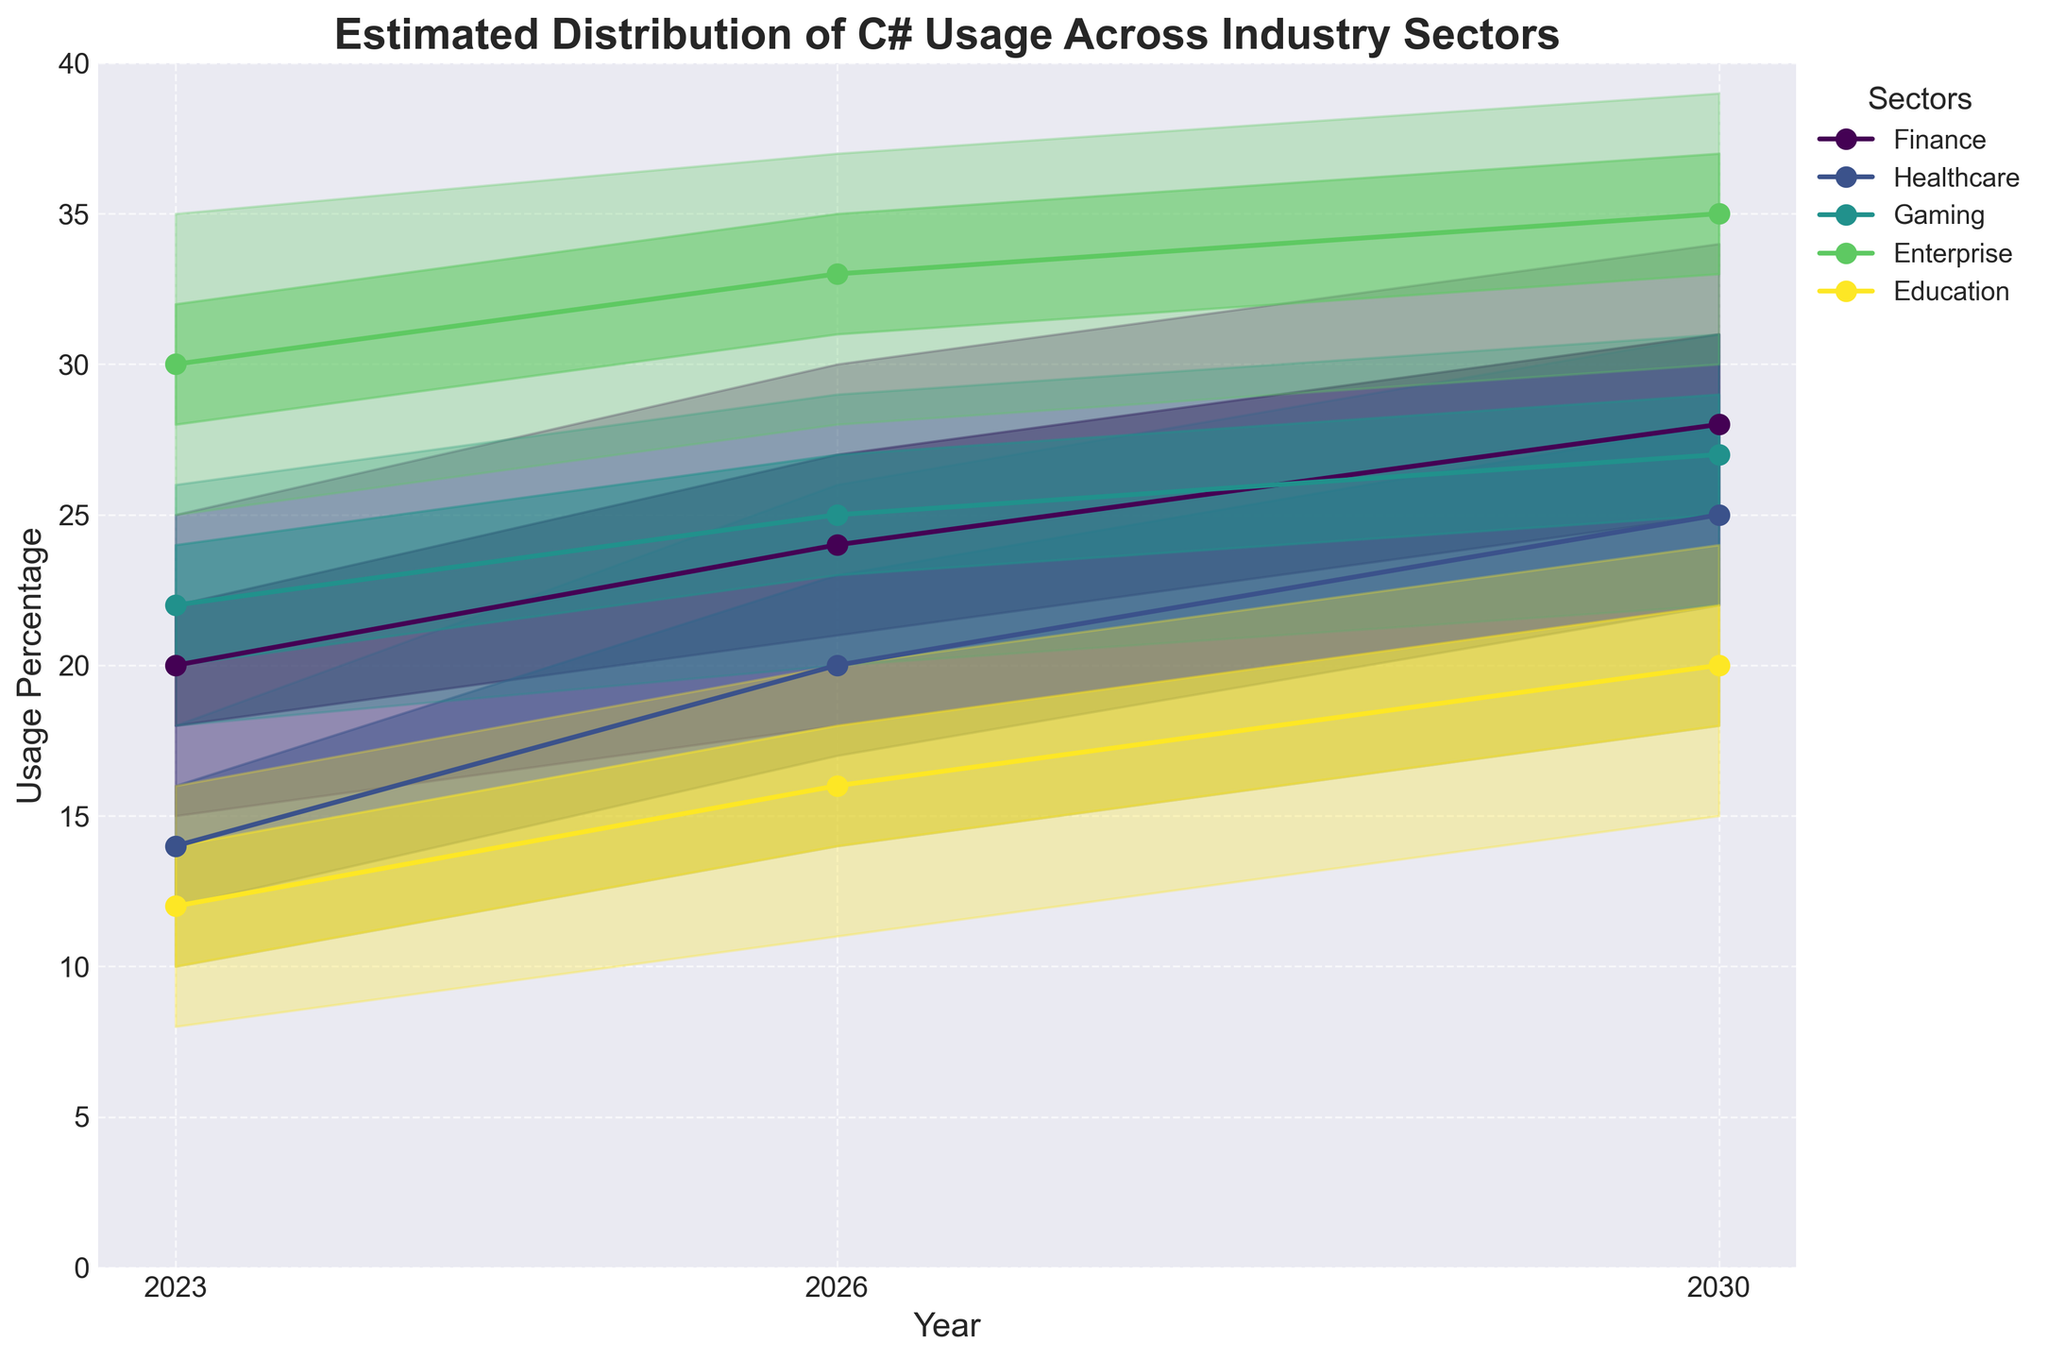How many industry sectors are represented in the chart? There are 5 unique sectors listed in the data table: Finance, Healthcare, Gaming, Enterprise, and Education
Answer: 5 What is the title of the chart? The title of the chart is displayed at the top of the figure.
Answer: Estimated Distribution of C# Usage Across Industry Sectors Which sector has the highest median estimated usage in 2023? Look at the values in the "Mid" column for 2023: Finance (20), Healthcare (14), Gaming (22), Enterprise (30), Education (12). Enterprise has the highest value.
Answer: Enterprise How does the estimated usage of C# in Healthcare in 2023 compare to that in 2030 according to the median values? Compare the median values for Healthcare in 2023 and 2030: 14 (2023) and 25 (2030).
Answer: It increases In 2026, which sectors are estimated to have a higher mid value than Gaming? Look at the mid values for all sectors in 2026: Finance (24), Healthcare (20), Gaming (25), Enterprise (33), Education (16). Only Enterprise has a higher mid value than Gaming.
Answer: Enterprise What is the range of estimated C# usage for the Finance sector in 2030? The range is the difference between the high and low values: 34 (High) - 22 (Low) = 12
Answer: 12 Which year shows the highest overall estimated usage for the Education sector in the HighMid range? Review the HighMid values for Education for each year: 2023 (14), 2026 (18), 2030 (22). The highest value is in 2030.
Answer: 2030 How does the estimated increase in mid value for Gaming from 2023 to 2026 compare to that from 2026 to 2030? Calculate the changes in mid values: 25 (2026) - 22 (2023) = 3 and 27 (2030) - 25 (2026) = 2.
Answer: The increase from 2023 to 2026 is greater Which sector shows the least variability in estimated usage in 2026, based on the Low and High values? Variance can be approximated by the range (High - Low). Calculate for each sector in 2026: Finance (30-18=12), Healthcare (26-14=12), Gaming (29-20=9), Enterprise (37-28=9), Education (20-11=9). Gaming, Enterprise, and Education have the least variability.
Answer: Gaming, Enterprise, Education 